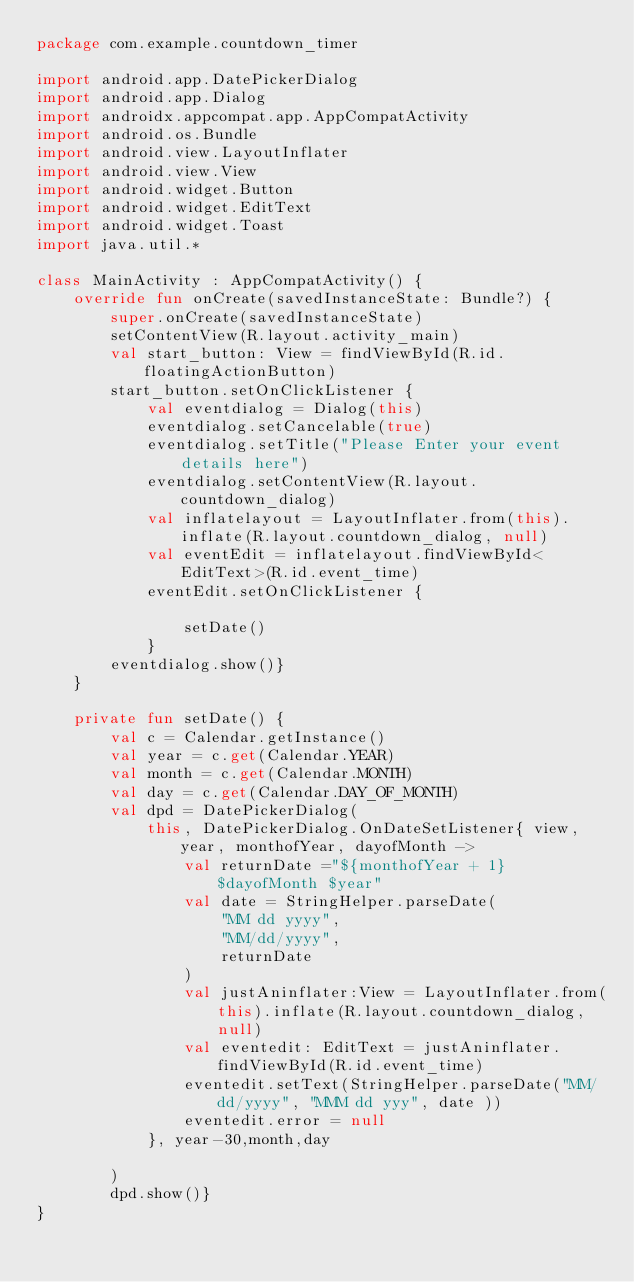Convert code to text. <code><loc_0><loc_0><loc_500><loc_500><_Kotlin_>package com.example.countdown_timer

import android.app.DatePickerDialog
import android.app.Dialog
import androidx.appcompat.app.AppCompatActivity
import android.os.Bundle
import android.view.LayoutInflater
import android.view.View
import android.widget.Button
import android.widget.EditText
import android.widget.Toast
import java.util.*

class MainActivity : AppCompatActivity() {
    override fun onCreate(savedInstanceState: Bundle?) {
        super.onCreate(savedInstanceState)
        setContentView(R.layout.activity_main)
        val start_button: View = findViewById(R.id.floatingActionButton)
        start_button.setOnClickListener {
            val eventdialog = Dialog(this)
            eventdialog.setCancelable(true)
            eventdialog.setTitle("Please Enter your event details here")
            eventdialog.setContentView(R.layout.countdown_dialog)
            val inflatelayout = LayoutInflater.from(this).inflate(R.layout.countdown_dialog, null)
            val eventEdit = inflatelayout.findViewById<EditText>(R.id.event_time)
            eventEdit.setOnClickListener {

                setDate()
            }
        eventdialog.show()}
    }

    private fun setDate() {
        val c = Calendar.getInstance()
        val year = c.get(Calendar.YEAR)
        val month = c.get(Calendar.MONTH)
        val day = c.get(Calendar.DAY_OF_MONTH)
        val dpd = DatePickerDialog(
            this, DatePickerDialog.OnDateSetListener{ view, year, monthofYear, dayofMonth ->
                val returnDate ="${monthofYear + 1} $dayofMonth $year"
                val date = StringHelper.parseDate(
                    "MM dd yyyy",
                    "MM/dd/yyyy",
                    returnDate
                )
                val justAninflater:View = LayoutInflater.from(this).inflate(R.layout.countdown_dialog, null)
                val eventedit: EditText = justAninflater.findViewById(R.id.event_time)
                eventedit.setText(StringHelper.parseDate("MM/dd/yyyy", "MMM dd yyy", date ))
                eventedit.error = null
            }, year-30,month,day

        )
        dpd.show()}
}

</code> 